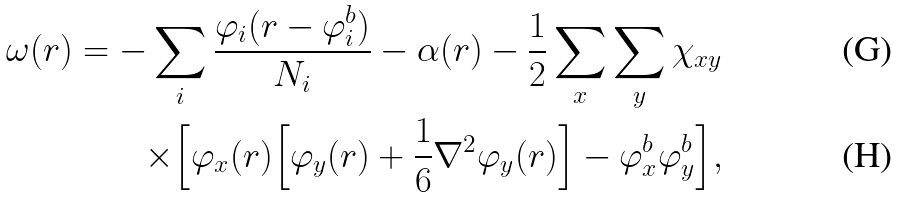<formula> <loc_0><loc_0><loc_500><loc_500>\omega ( r ) = - \sum _ { i } \frac { \varphi _ { i } ( r - \varphi _ { i } ^ { b } ) } { N _ { i } } - \alpha ( r ) - \frac { 1 } { 2 } \sum _ { x } \sum _ { y } \chi _ { x y } \\ \times \Big { [ } \varphi _ { x } ( r ) \Big { [ } \varphi _ { y } ( r ) + \frac { 1 } { 6 } \nabla ^ { 2 } \varphi _ { y } ( r ) \Big { ] } - \varphi _ { x } ^ { b } \varphi _ { y } ^ { b } \Big { ] } ,</formula> 